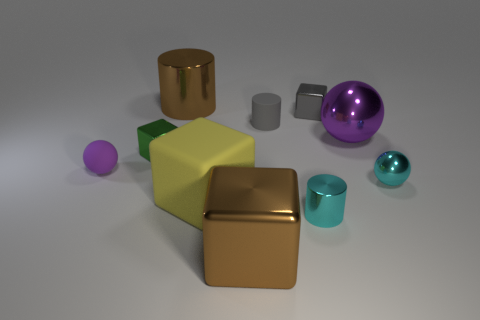What number of things are the same material as the big sphere?
Provide a short and direct response. 6. What is the size of the brown shiny thing behind the ball that is behind the green object?
Ensure brevity in your answer.  Large. There is a tiny object that is on the left side of the cyan metallic cylinder and on the right side of the tiny green shiny block; what is its color?
Your answer should be compact. Gray. Do the gray shiny thing and the big purple thing have the same shape?
Provide a succinct answer. No. What is the size of the thing that is the same color as the small matte sphere?
Your answer should be compact. Large. What is the shape of the tiny metallic object to the right of the tiny cube behind the small matte cylinder?
Ensure brevity in your answer.  Sphere. Do the green thing and the brown metal object that is in front of the large matte thing have the same shape?
Give a very brief answer. Yes. What is the color of the metal sphere that is the same size as the matte block?
Offer a very short reply. Purple. Are there fewer brown shiny blocks that are behind the cyan shiny sphere than big brown metal things in front of the large brown cylinder?
Offer a terse response. Yes. What shape is the purple thing that is left of the big brown metallic thing on the right side of the large brown shiny thing that is behind the tiny purple ball?
Your answer should be very brief. Sphere. 